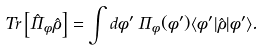Convert formula to latex. <formula><loc_0><loc_0><loc_500><loc_500>T r \left [ \hat { \Pi } _ { \phi } \hat { \rho } \right ] = \int d \phi ^ { \prime } \, \Pi _ { \phi } ( \phi ^ { \prime } ) \langle \phi ^ { \prime } | \hat { \rho } | \phi ^ { \prime } \rangle .</formula> 